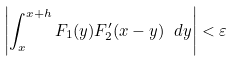Convert formula to latex. <formula><loc_0><loc_0><loc_500><loc_500>\left | \int _ { x } ^ { x + h } F _ { 1 } ( y ) F _ { 2 } ^ { \prime } ( x - y ) \ d y \right | < \varepsilon</formula> 